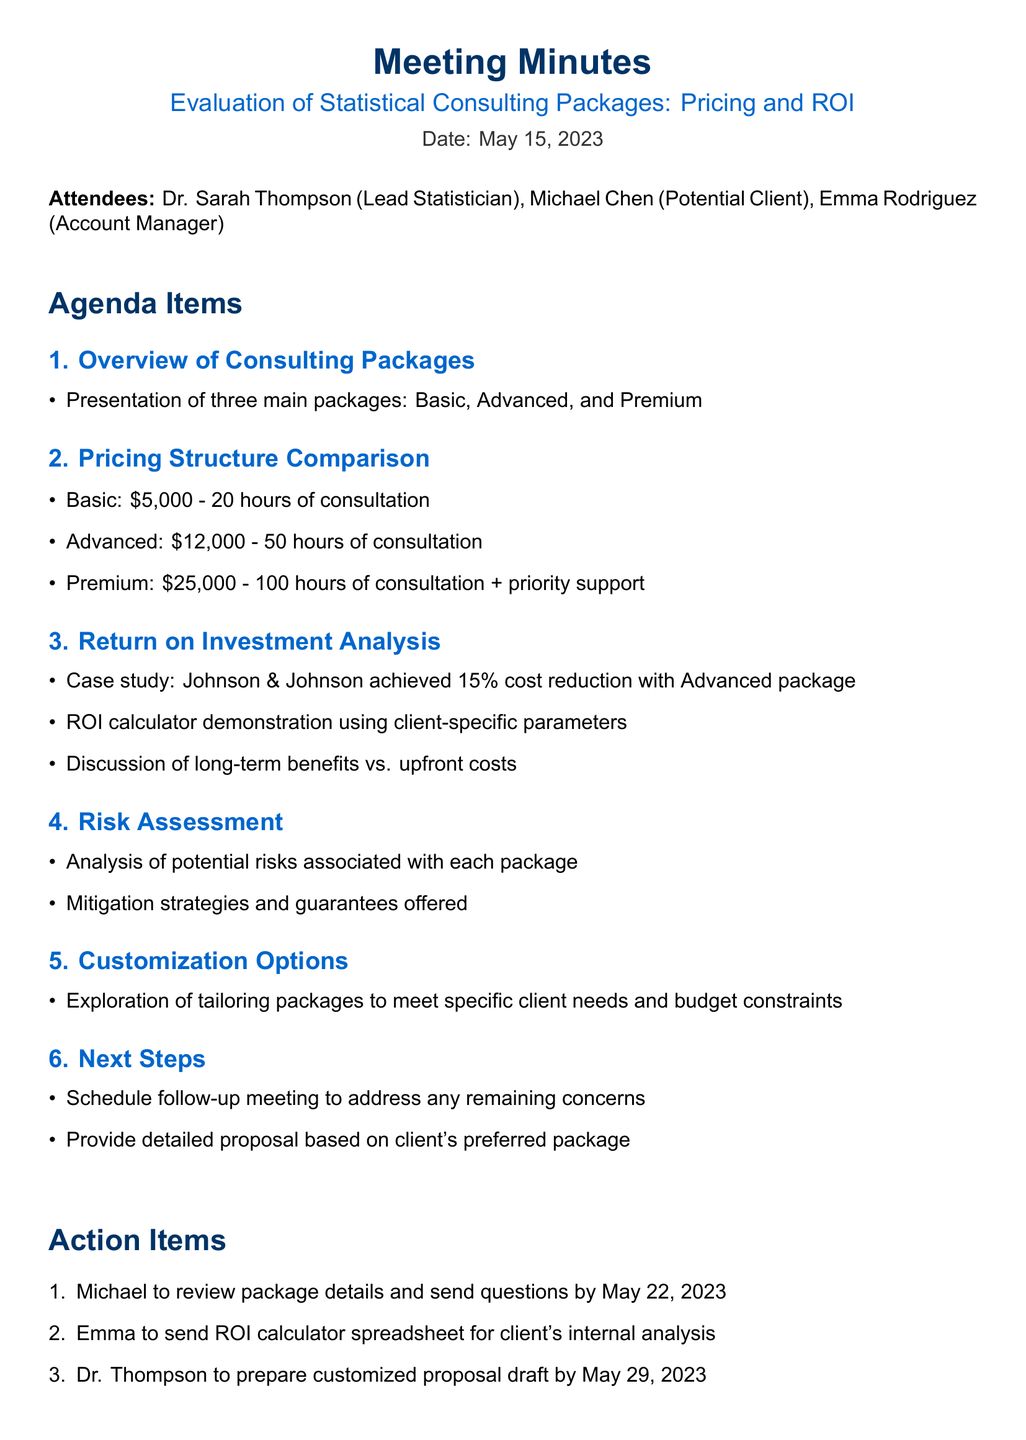What is the title of the meeting? The title of the meeting is stated at the beginning of the document.
Answer: Evaluation of Statistical Consulting Packages: Pricing and ROI Who presented the Basic package? The attendees included a lead statistician, but the document does not mention who specifically presented each package.
Answer: Not specified How much does the Advanced package cost? This information is provided in the pricing structure section of the document.
Answer: $12,000 What was the ROI achieved by Johnson & Johnson? The ROI for Johnson & Johnson is mentioned in the Return on Investment Analysis section.
Answer: 15% When is the deadline for Michael to send questions? This date is given in the action items section of the document.
Answer: May 22, 2023 What are the three main consulting packages? The names of the packages are listed under the Overview of Consulting Packages section.
Answer: Basic, Advanced, Premium How many hours of consultation does the Premium package include? The number of consultation hours for this package is mentioned in the pricing structure.
Answer: 100 hours Which attendee is responsible for preparing the customized proposal draft? The action items section specifies who is responsible for this task.
Answer: Dr. Thompson 